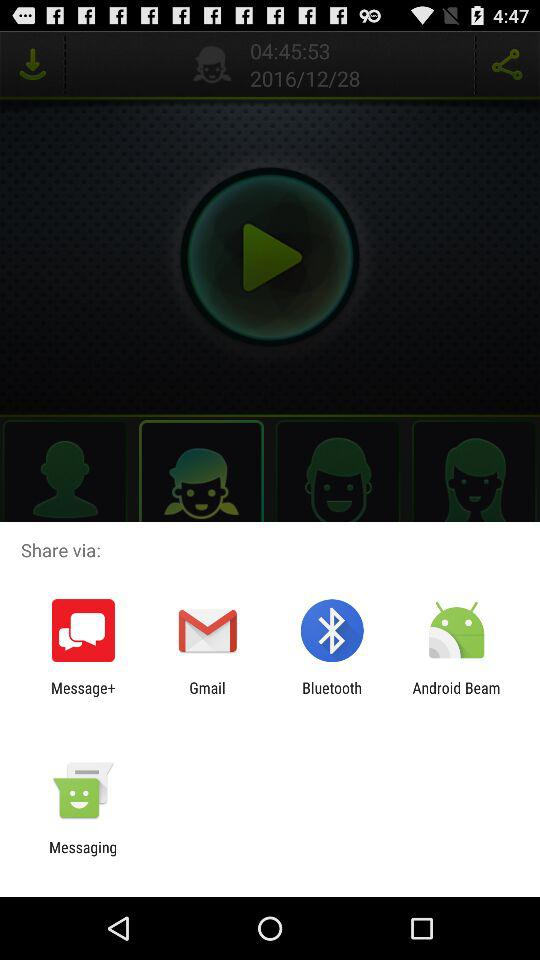What are the different options available for sharing? The available options for sharing are "Message+", "Gmail", "Bluetooth", "Android Beam" and "Messaging". 